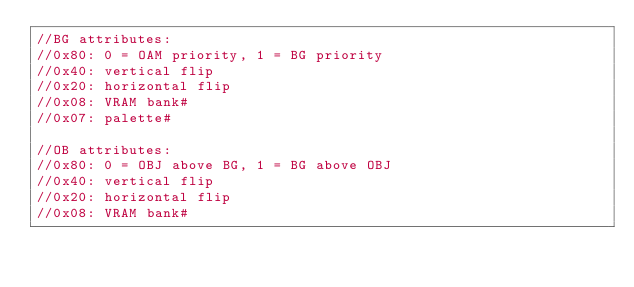<code> <loc_0><loc_0><loc_500><loc_500><_C++_>//BG attributes:
//0x80: 0 = OAM priority, 1 = BG priority
//0x40: vertical flip
//0x20: horizontal flip
//0x08: VRAM bank#
//0x07: palette#

//OB attributes:
//0x80: 0 = OBJ above BG, 1 = BG above OBJ
//0x40: vertical flip
//0x20: horizontal flip
//0x08: VRAM bank#</code> 